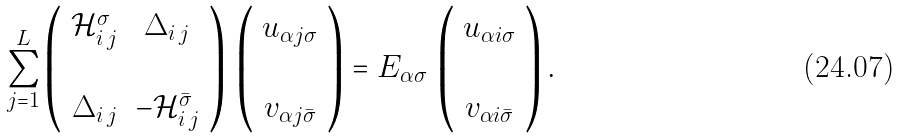<formula> <loc_0><loc_0><loc_500><loc_500>\sum _ { j = 1 } ^ { L } \left ( \begin{array} { c c c } \mathcal { H } ^ { \sigma } _ { i \, j } & \Delta _ { i \, j } \\ \\ \Delta _ { i \, j } & - \mathcal { H } ^ { \bar { \sigma } } _ { i \, j } \\ \end{array} \right ) \, \left ( \begin{array} { c } u _ { \alpha j \sigma } \\ \\ v _ { \alpha j \bar { \sigma } } \\ \end{array} \right ) = E _ { \alpha \sigma } \, \left ( \begin{array} { c } u _ { \alpha i \sigma } \\ \\ v _ { \alpha i \bar { \sigma } } \\ \end{array} \right ) .</formula> 